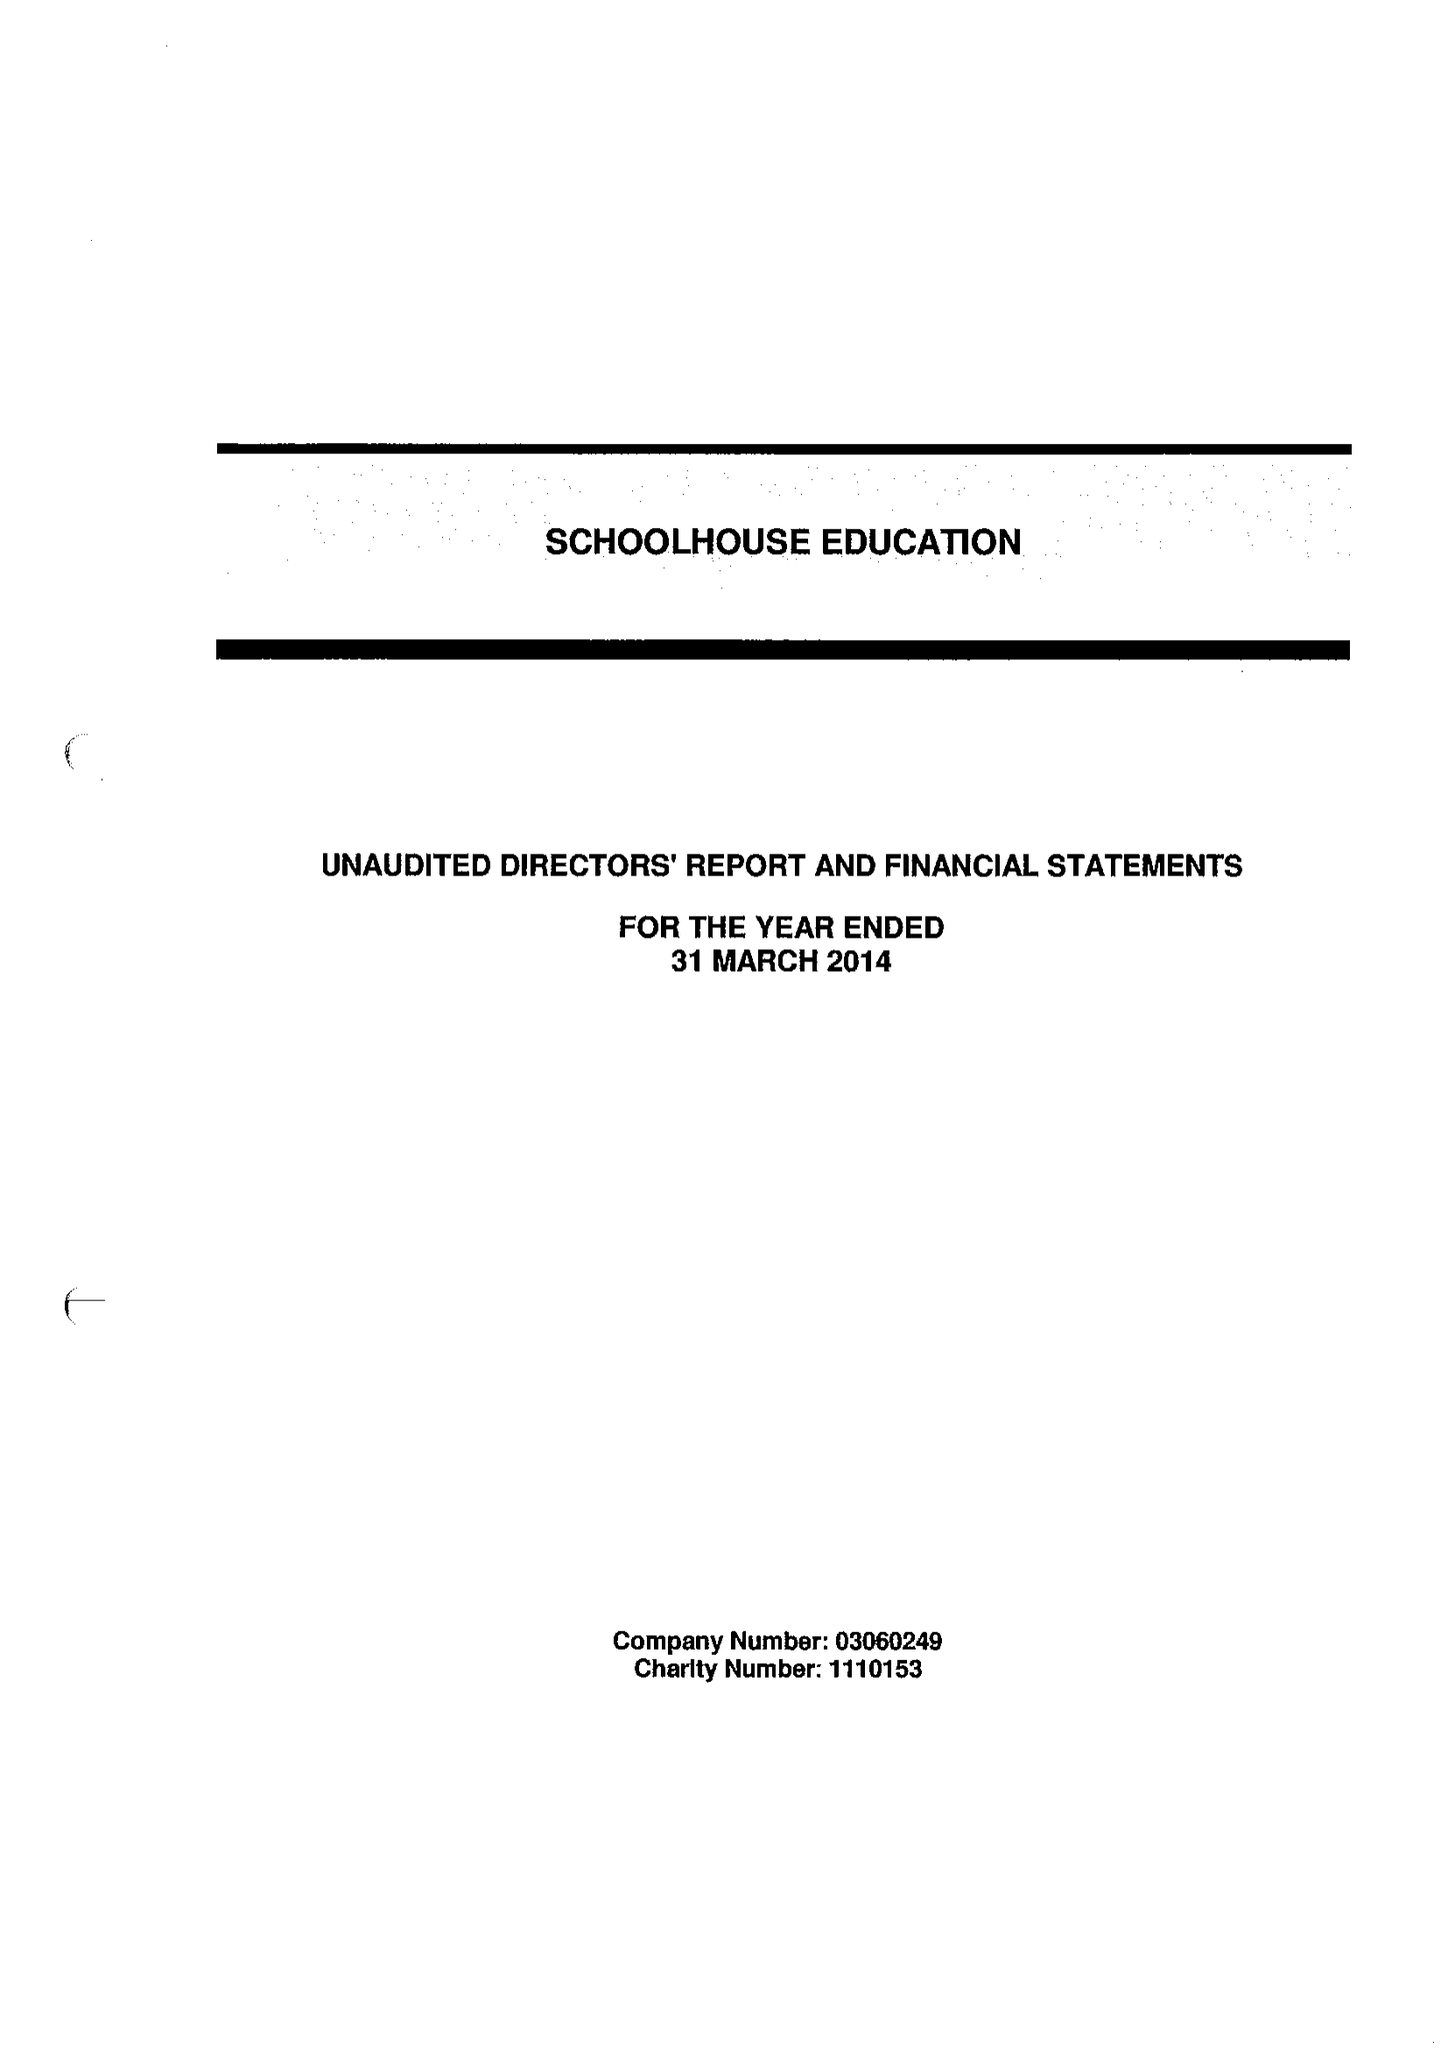What is the value for the address__postcode?
Answer the question using a single word or phrase. SE2 9LZ 